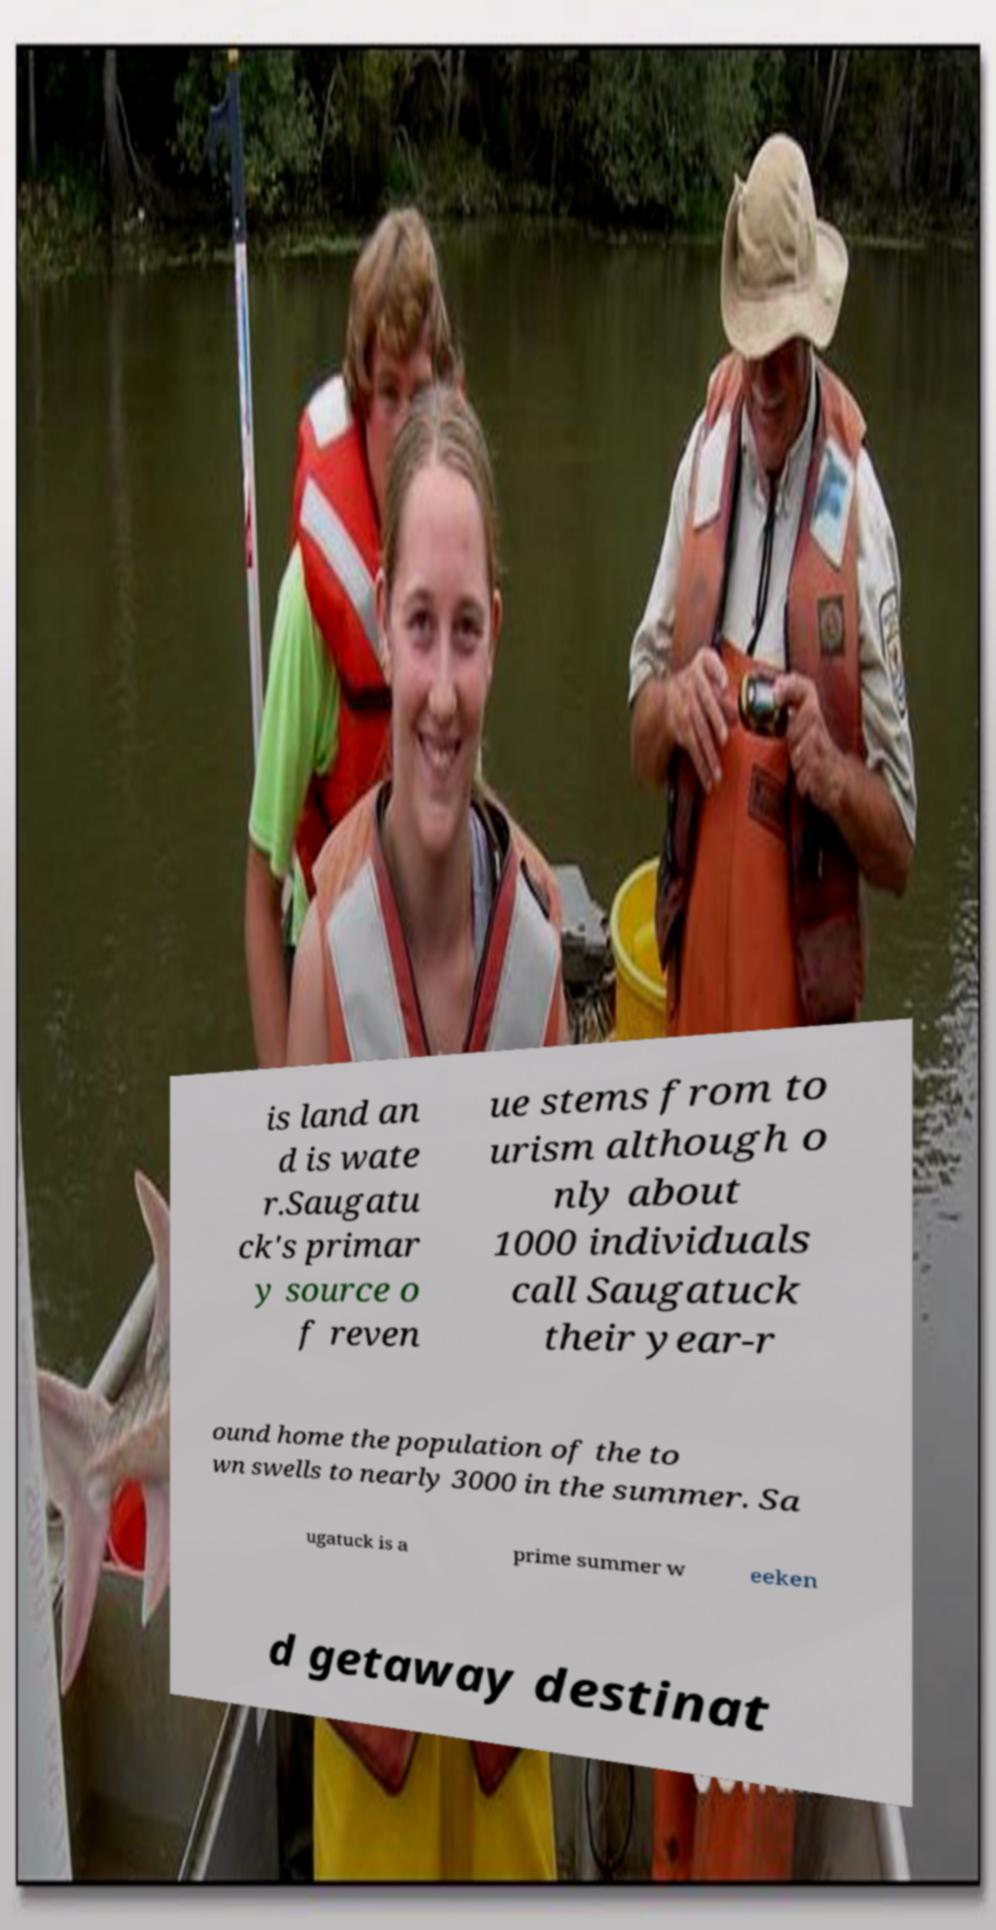There's text embedded in this image that I need extracted. Can you transcribe it verbatim? is land an d is wate r.Saugatu ck's primar y source o f reven ue stems from to urism although o nly about 1000 individuals call Saugatuck their year-r ound home the population of the to wn swells to nearly 3000 in the summer. Sa ugatuck is a prime summer w eeken d getaway destinat 